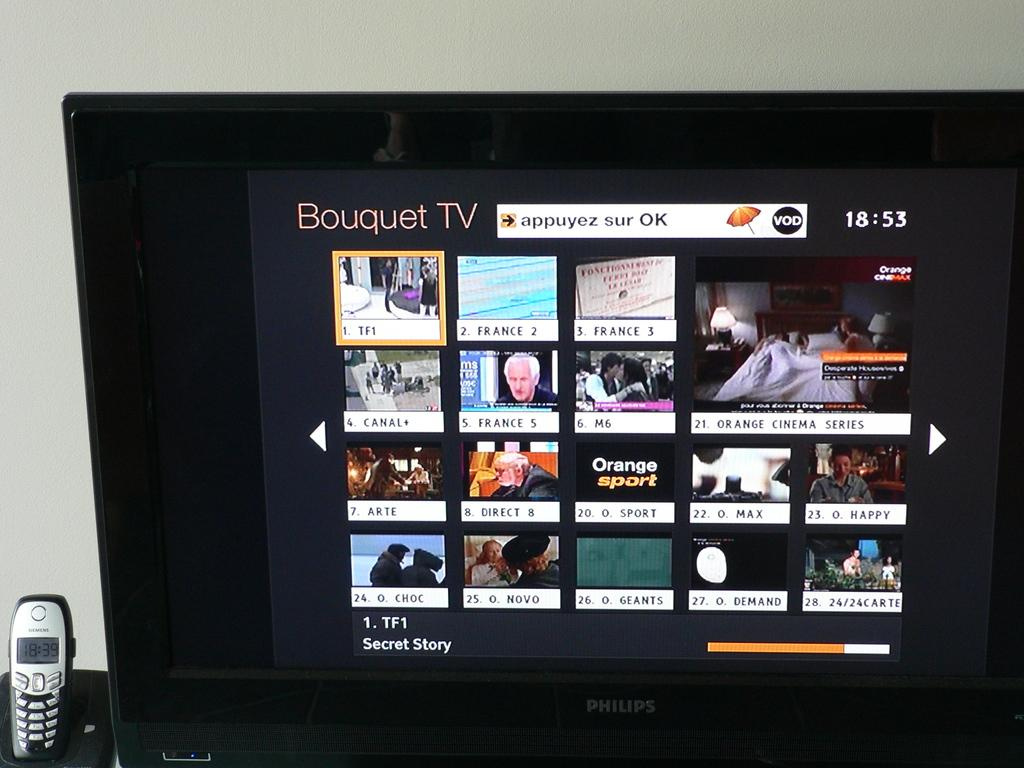<image>
Share a concise interpretation of the image provided. a screen that says Bouquet tv at the top 